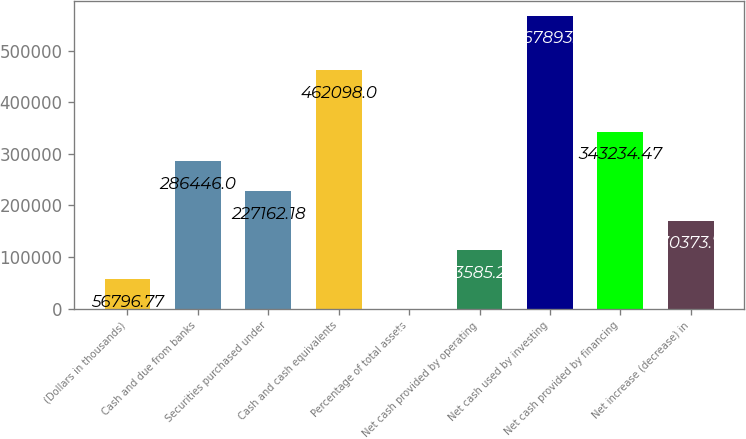Convert chart. <chart><loc_0><loc_0><loc_500><loc_500><bar_chart><fcel>(Dollars in thousands)<fcel>Cash and due from banks<fcel>Securities purchased under<fcel>Cash and cash equivalents<fcel>Percentage of total assets<fcel>Net cash provided by operating<fcel>Net cash used by investing<fcel>Net cash provided by financing<fcel>Net increase (decrease) in<nl><fcel>56796.8<fcel>286446<fcel>227162<fcel>462098<fcel>8.3<fcel>113585<fcel>567893<fcel>343234<fcel>170374<nl></chart> 